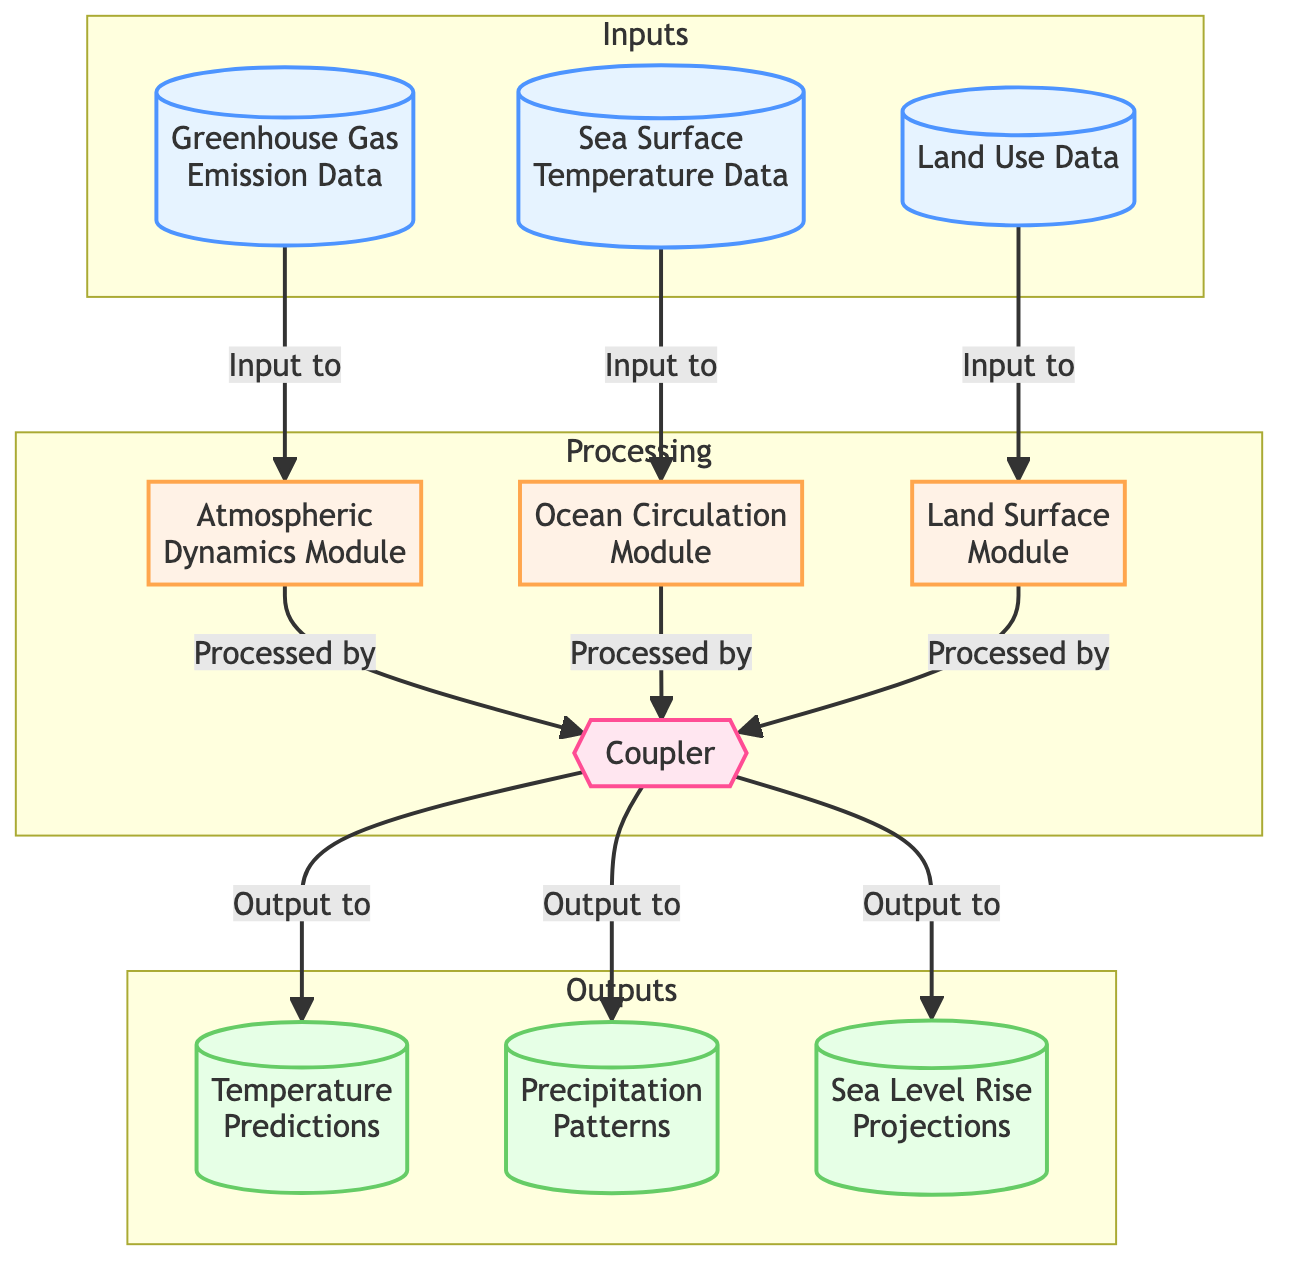What are the inputs to the Atmospheric Dynamics Module? The diagram shows that the Atmospheric Dynamics Module receives input from the Greenhouse Gas Emission Data, which is labeled as node 1, through a directed edge that indicates the relationship. Thus, Greenhouse Gas Emission Data is the input to this module.
Answer: Greenhouse Gas Emission Data How many processing units are in the diagram? The diagram illustrates the various processing units, which are outlined in the "Processing" subgraph. There are four processing units: Atmospheric Dynamics Module, Ocean Circulation Module, Land Surface Module, and the Coupler.
Answer: 4 What data source is used for the Sea Surface Temperature Data? By inspecting node 2 for Sea Surface Temperature Data, we can see that it specifies the data source as NOAA Satellite Observations. This information is directly labeled in the node.
Answer: NOAA Satellite Observations Which module processes the output projections? The diagram indicates that the Coupler, represented as node 7, is responsible for processing and sending output to the three output nodes. This is denoted by the edges leading from the Coupler to Temperature Predictions, Precipitation Patterns, and Sea Level Rise Projections.
Answer: Coupler What format is used for the Temperature Predictions output? According to the label for the Temperature Predictions node (node 8), the output format is specified as NetCDF. This is directly stated in the node's description.
Answer: NetCDF What is the relationship between Land Use Data and the Land Surface Module? The diagram shows that Land Use Data (node 3) is an input to the Land Surface Module (node 6). This connection is made clear by the directed edge from node 3 to node 6 labeled as "Input to."
Answer: Input to Which input is processed by the Ocean Circulation Module? The diagram clearly indicates that the Sea Surface Temperature Data (node 2) is processed by the Ocean Circulation Module (node 5) as it has a directed edge indicating the input relationship.
Answer: Sea Surface Temperature Data How many outputs are there in the diagram? By reviewing the Outputs subgraph, we find three separate nodes for outputs: Temperature Predictions, Precipitation Patterns, and Sea Level Rise Projections. This information is visible in the structure of the diagram.
Answer: 3 